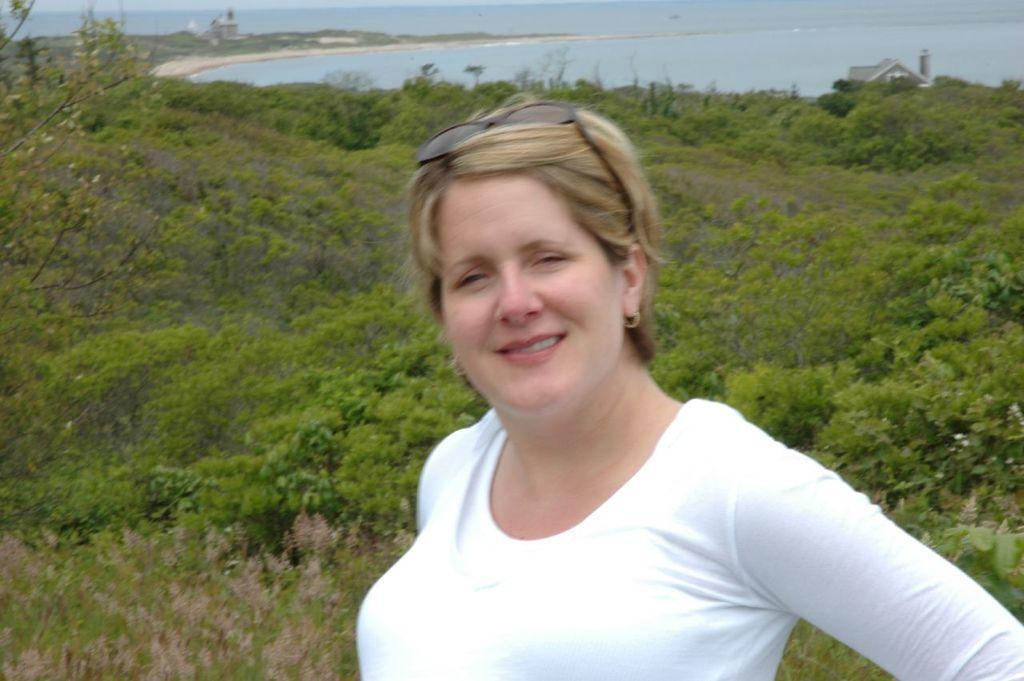How would you summarize this image in a sentence or two? Front this woman wore white t-shirt and smiling. Background there are plants and water. Far there is a house. 